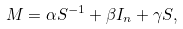<formula> <loc_0><loc_0><loc_500><loc_500>M = \alpha S ^ { - 1 } + \beta I _ { n } + \gamma S ,</formula> 